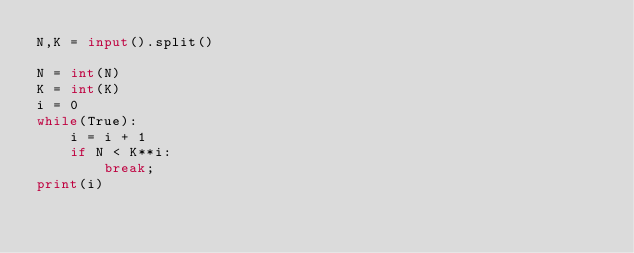Convert code to text. <code><loc_0><loc_0><loc_500><loc_500><_Python_>N,K = input().split()

N = int(N)
K = int(K)
i = 0
while(True):
    i = i + 1
    if N < K**i:
        break;
print(i)</code> 